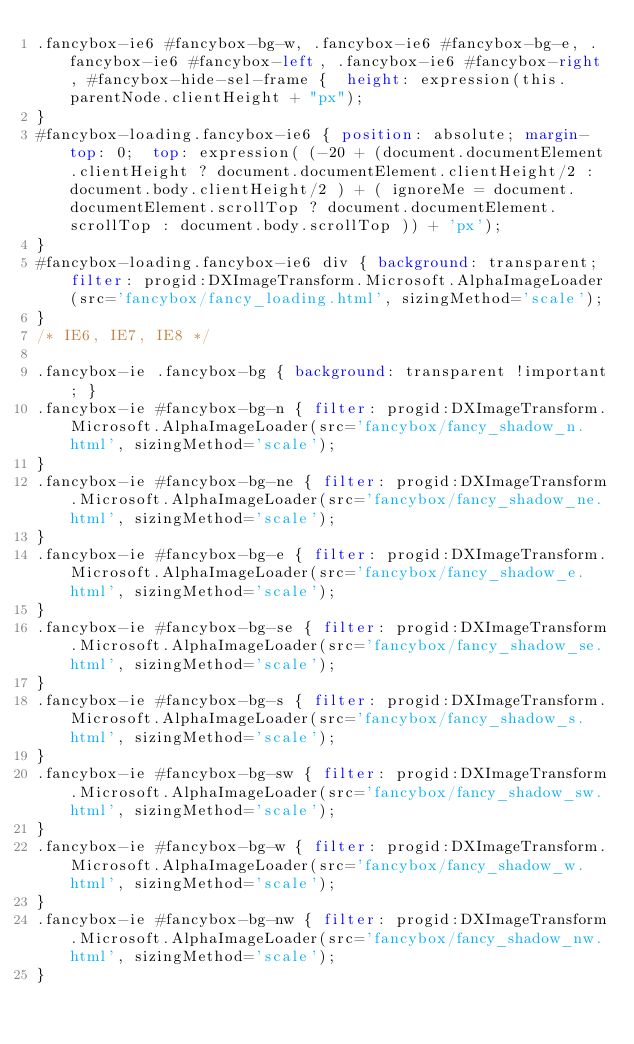<code> <loc_0><loc_0><loc_500><loc_500><_CSS_>.fancybox-ie6 #fancybox-bg-w, .fancybox-ie6 #fancybox-bg-e, .fancybox-ie6 #fancybox-left, .fancybox-ie6 #fancybox-right, #fancybox-hide-sel-frame {  height: expression(this.parentNode.clientHeight + "px");
}
#fancybox-loading.fancybox-ie6 { position: absolute; margin-top: 0;  top: expression( (-20 + (document.documentElement.clientHeight ? document.documentElement.clientHeight/2 : document.body.clientHeight/2 ) + ( ignoreMe = document.documentElement.scrollTop ? document.documentElement.scrollTop : document.body.scrollTop )) + 'px');
}
#fancybox-loading.fancybox-ie6 div { background: transparent; filter: progid:DXImageTransform.Microsoft.AlphaImageLoader(src='fancybox/fancy_loading.html', sizingMethod='scale');
}
/* IE6, IE7, IE8 */

.fancybox-ie .fancybox-bg { background: transparent !important; }
.fancybox-ie #fancybox-bg-n { filter: progid:DXImageTransform.Microsoft.AlphaImageLoader(src='fancybox/fancy_shadow_n.html', sizingMethod='scale');
}
.fancybox-ie #fancybox-bg-ne { filter: progid:DXImageTransform.Microsoft.AlphaImageLoader(src='fancybox/fancy_shadow_ne.html', sizingMethod='scale');
}
.fancybox-ie #fancybox-bg-e { filter: progid:DXImageTransform.Microsoft.AlphaImageLoader(src='fancybox/fancy_shadow_e.html', sizingMethod='scale');
}
.fancybox-ie #fancybox-bg-se { filter: progid:DXImageTransform.Microsoft.AlphaImageLoader(src='fancybox/fancy_shadow_se.html', sizingMethod='scale');
}
.fancybox-ie #fancybox-bg-s { filter: progid:DXImageTransform.Microsoft.AlphaImageLoader(src='fancybox/fancy_shadow_s.html', sizingMethod='scale');
}
.fancybox-ie #fancybox-bg-sw { filter: progid:DXImageTransform.Microsoft.AlphaImageLoader(src='fancybox/fancy_shadow_sw.html', sizingMethod='scale');
}
.fancybox-ie #fancybox-bg-w { filter: progid:DXImageTransform.Microsoft.AlphaImageLoader(src='fancybox/fancy_shadow_w.html', sizingMethod='scale');
}
.fancybox-ie #fancybox-bg-nw { filter: progid:DXImageTransform.Microsoft.AlphaImageLoader(src='fancybox/fancy_shadow_nw.html', sizingMethod='scale');
}
</code> 